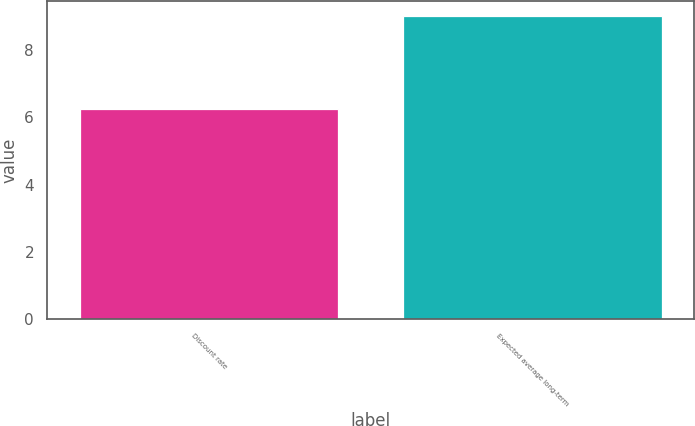Convert chart to OTSL. <chart><loc_0><loc_0><loc_500><loc_500><bar_chart><fcel>Discount rate<fcel>Expected average long-term<nl><fcel>6.25<fcel>9<nl></chart> 